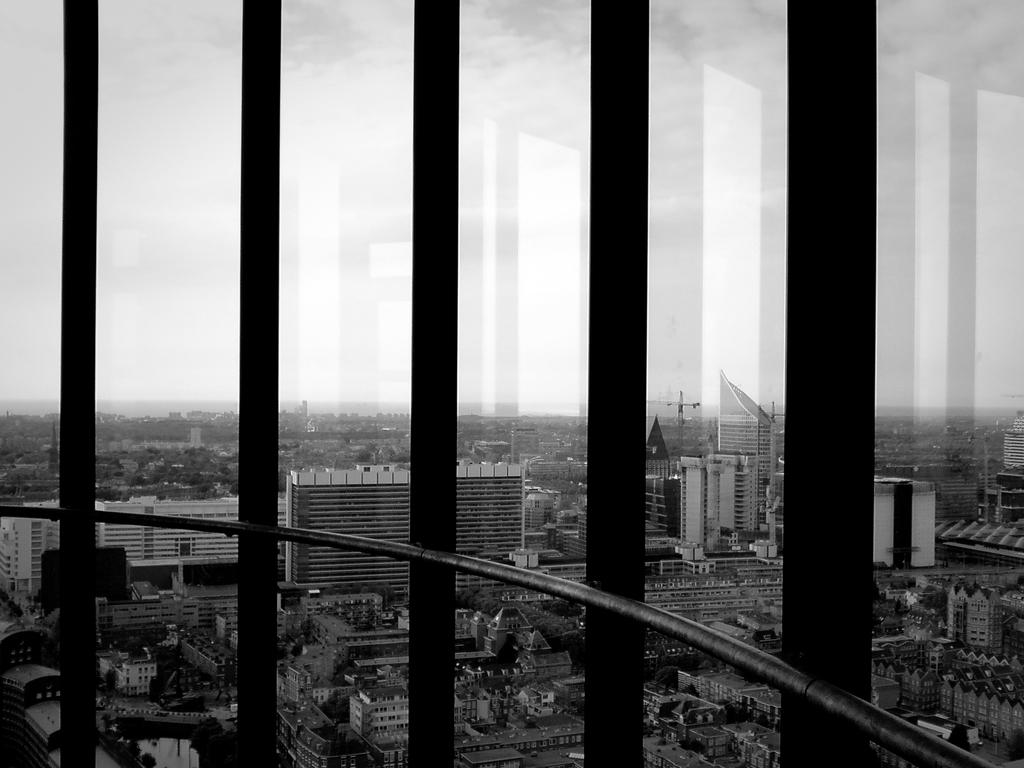What type of cooking appliance is present in the image? There is a grill made of metal in the image. What can be seen in the background of the image? Buildings and skyscrapers are visible in the background of the image. What is visible at the top of the image? The sky is visible at the top of the image. Is there a boy with a wound on his arm in the image? There is no boy or wound present in the image; it features a metal grill and a background with buildings and skyscrapers. Can you see a squirrel climbing the skyscraper in the image? There is no squirrel visible in the image; it only shows a metal grill and the background with buildings and skyscrapers. 